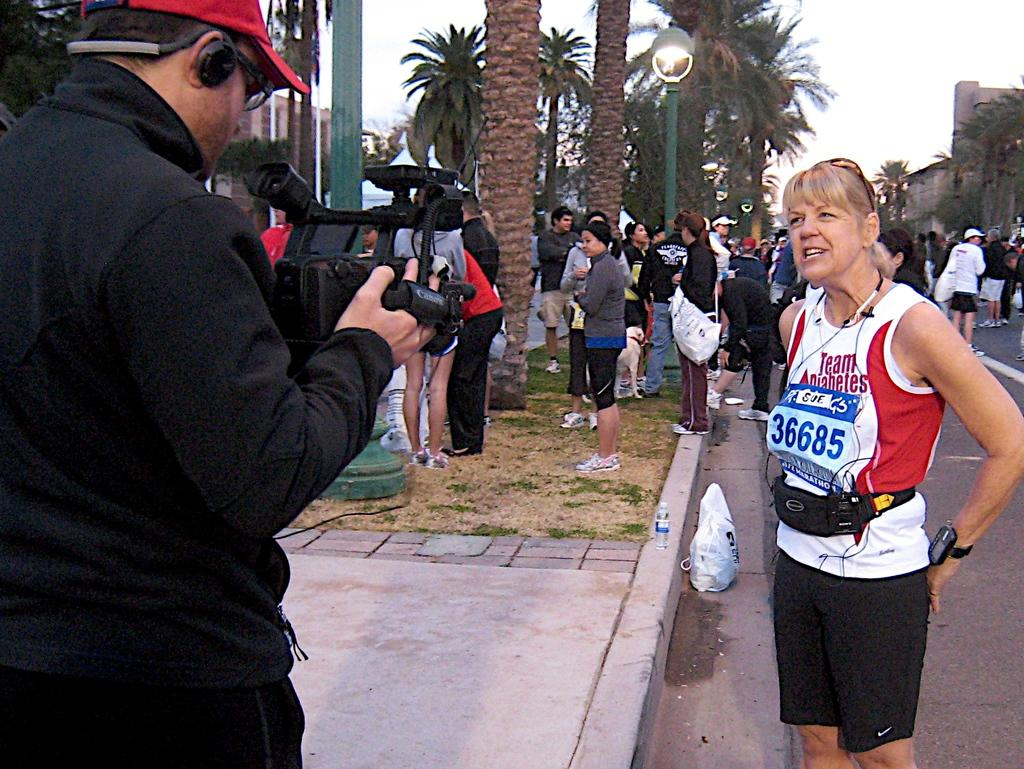<image>
Create a compact narrative representing the image presented. man with video camera focused on runner wearing team diabetes shirt and number 36685 